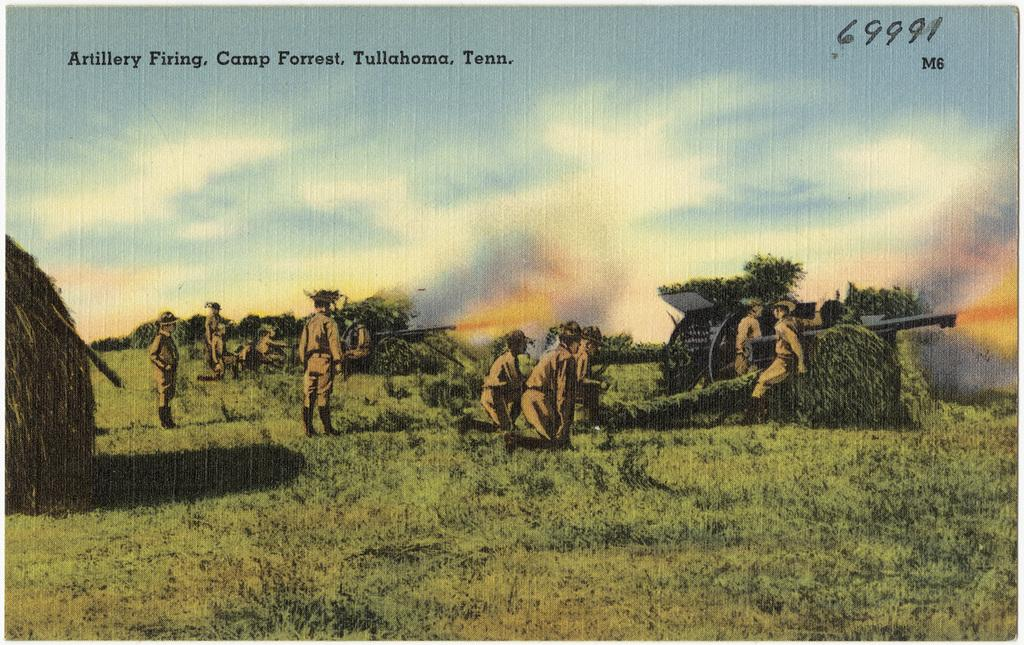What are the persons in the image wearing? The persons in the image are wearing uniforms. What are the persons in the image doing? The persons are standing. What objects can be seen in the image that might be used for defense or protection? Weapons are visible in the image. What can be seen in the background of the image? Trees, grass, and the sky are visible in the background of the image. What type of brush can be seen in the image? There is no brush present in the image. Can you hear a whistle in the image? There is no sound in the image, so it is not possible to hear a whistle. 